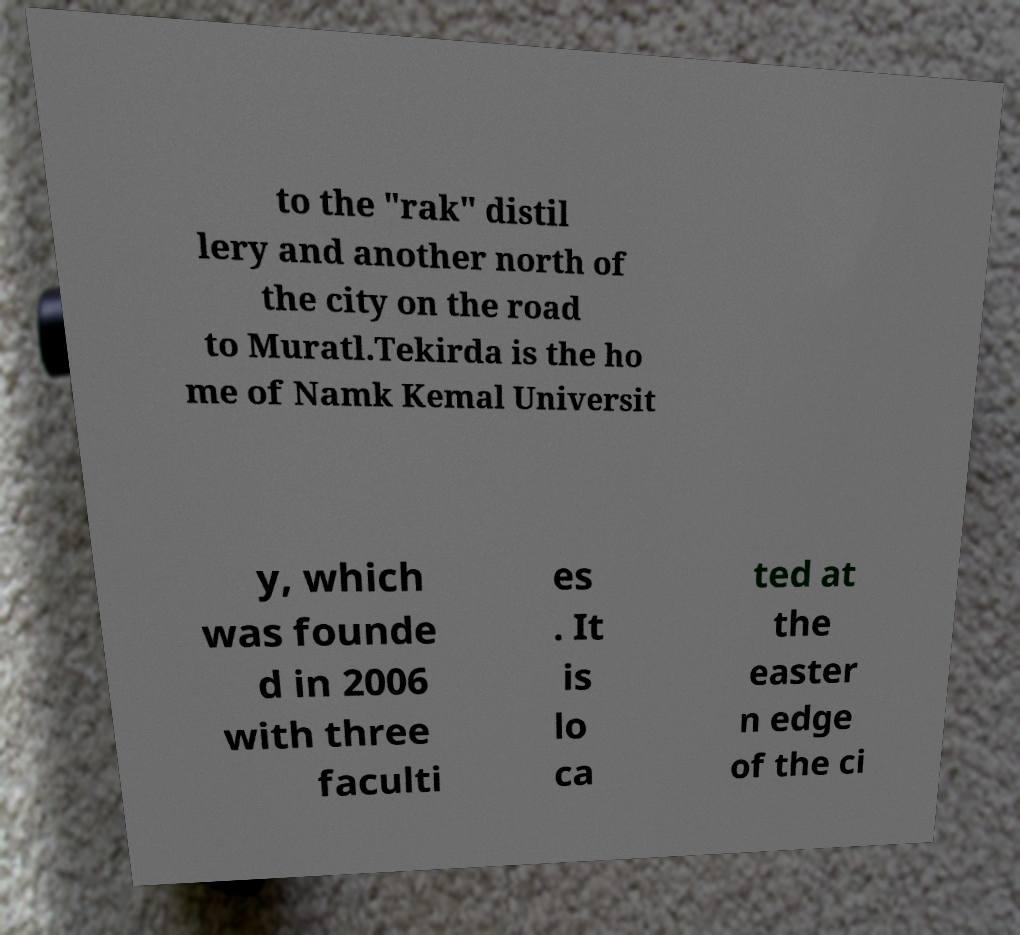What messages or text are displayed in this image? I need them in a readable, typed format. to the "rak" distil lery and another north of the city on the road to Muratl.Tekirda is the ho me of Namk Kemal Universit y, which was founde d in 2006 with three faculti es . It is lo ca ted at the easter n edge of the ci 